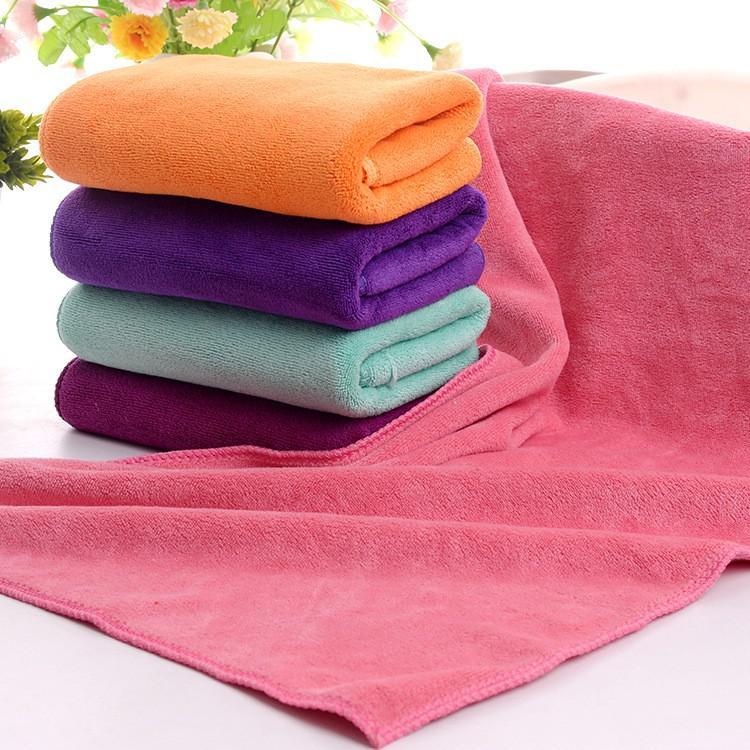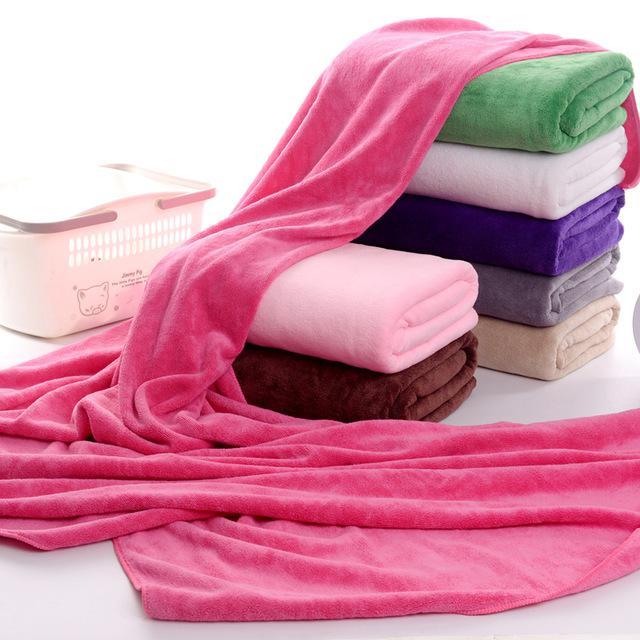The first image is the image on the left, the second image is the image on the right. Assess this claim about the two images: "In the image on the left the there is an orange towel at the top of a stack of towels.". Correct or not? Answer yes or no. Yes. The first image is the image on the left, the second image is the image on the right. Considering the images on both sides, is "In one image, a pink towel is draped over and around a single stack of seven or fewer folded towels in various colors." valid? Answer yes or no. Yes. 